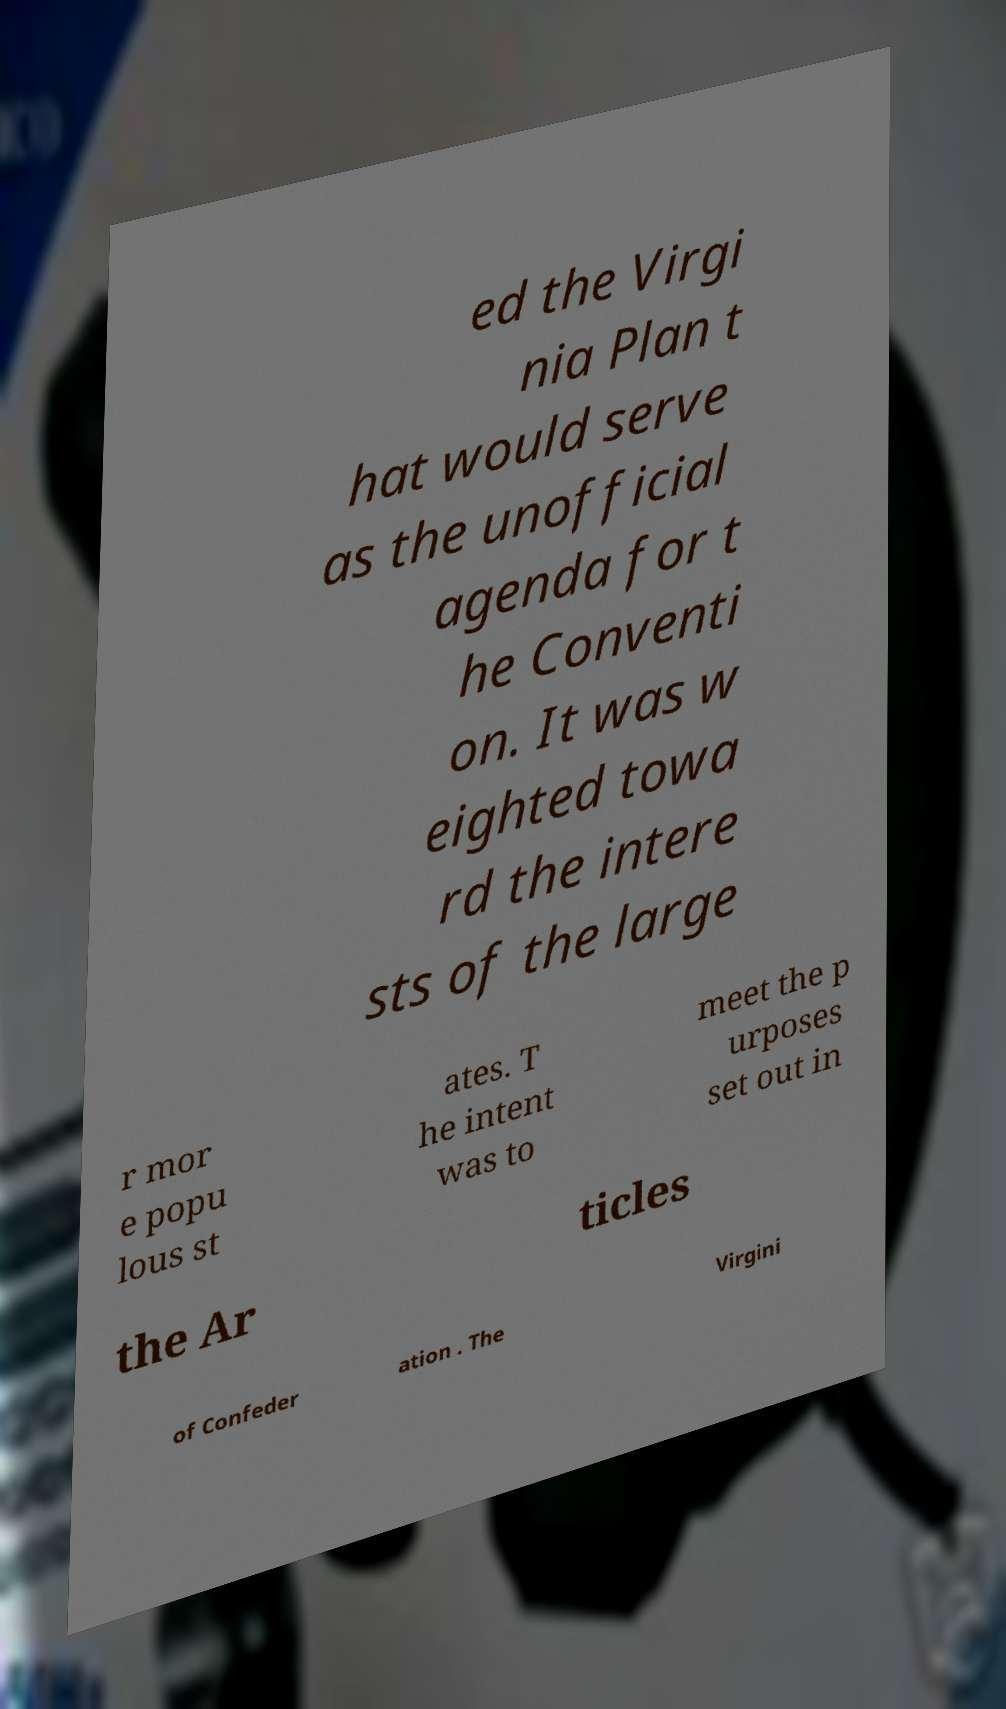For documentation purposes, I need the text within this image transcribed. Could you provide that? ed the Virgi nia Plan t hat would serve as the unofficial agenda for t he Conventi on. It was w eighted towa rd the intere sts of the large r mor e popu lous st ates. T he intent was to meet the p urposes set out in the Ar ticles of Confeder ation . The Virgini 